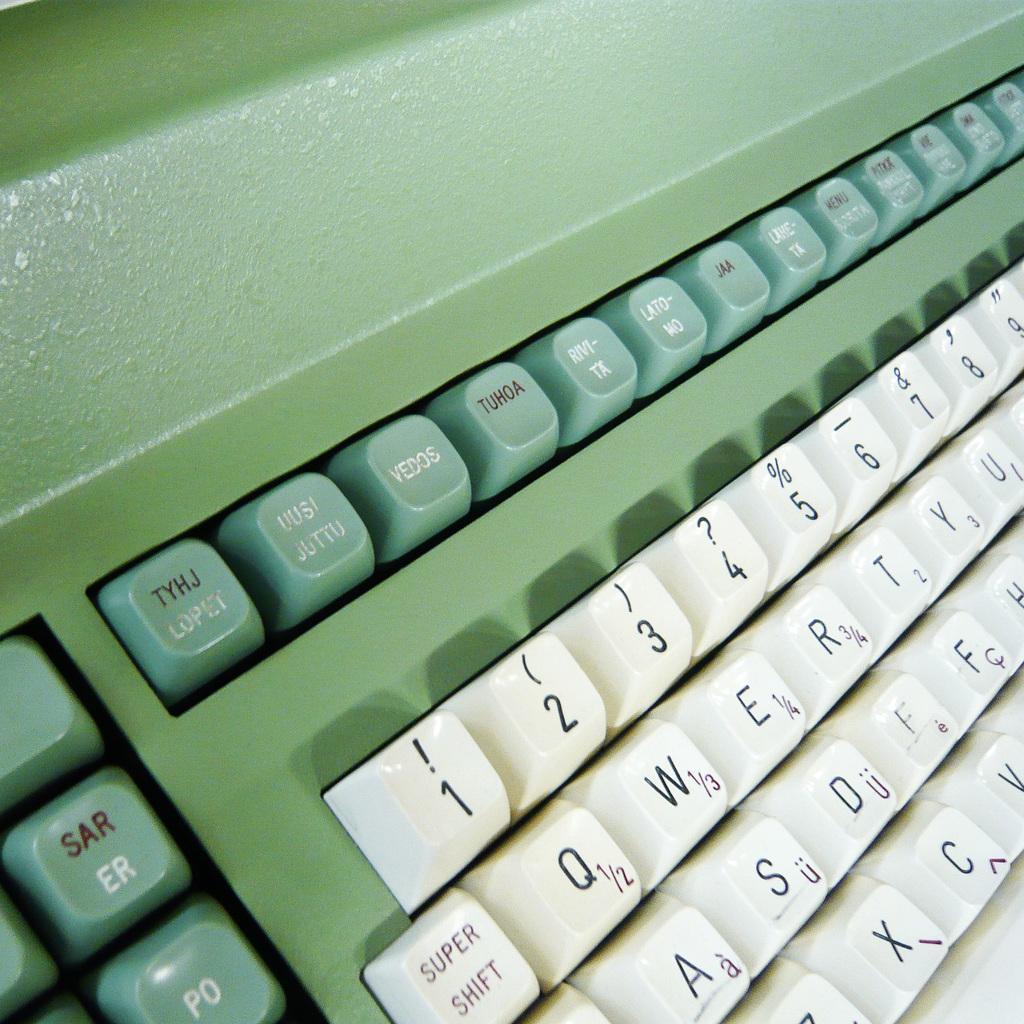<image>
Share a concise interpretation of the image provided. a keyboard with the letters qwert on it 